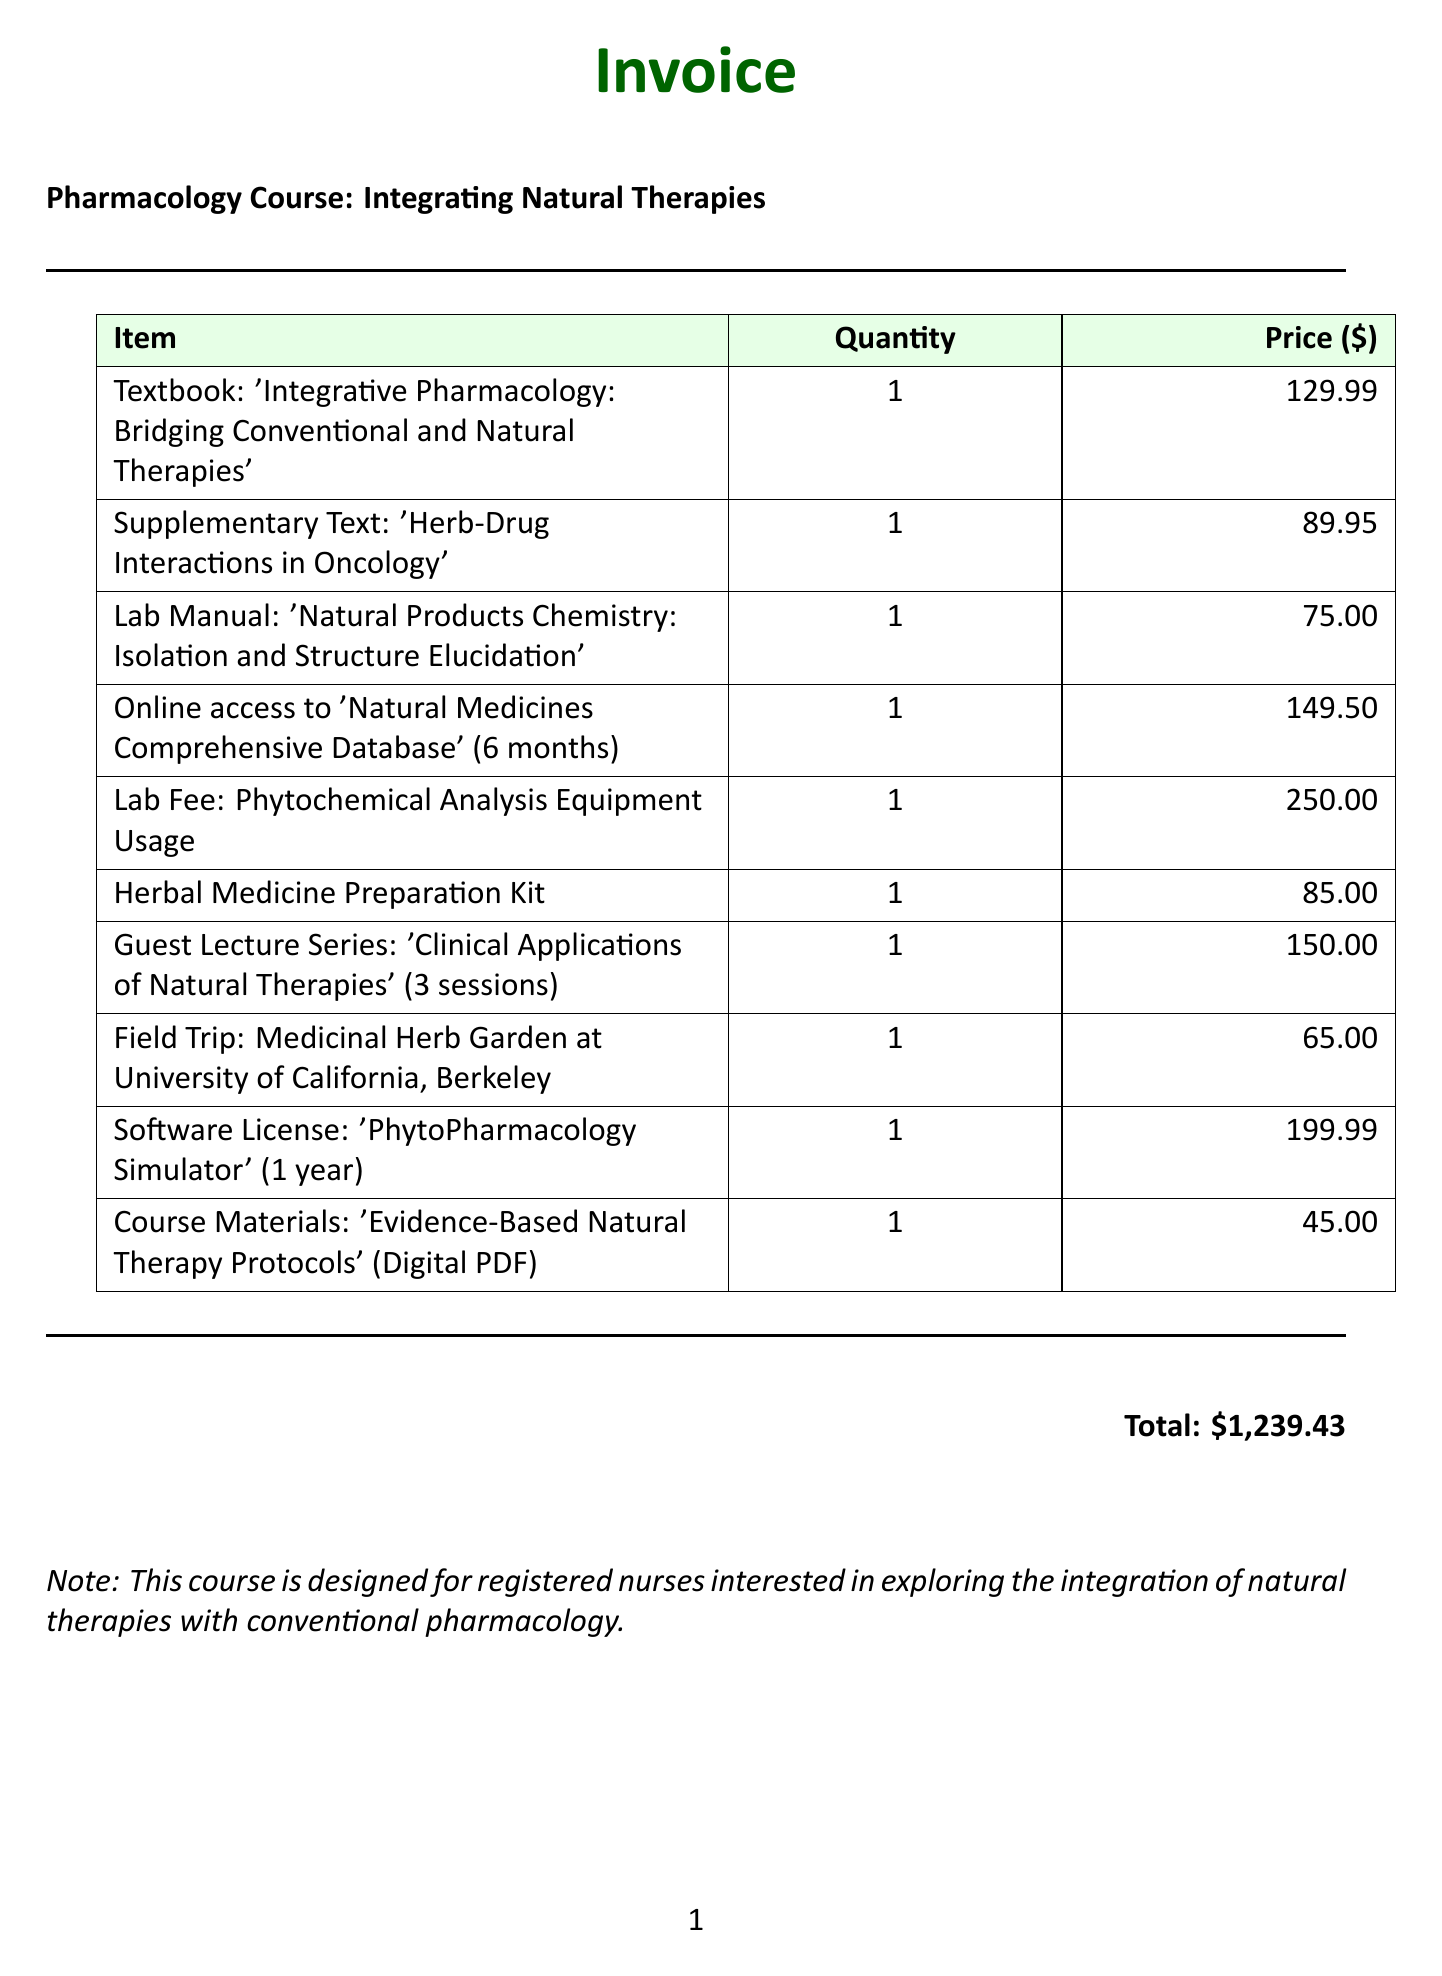What is the title of the main textbook? The title of the main textbook is provided in the list of invoice items.
Answer: 'Integrative Pharmacology: Bridging Conventional and Natural Therapies' Who are the authors of the supplementary text? The authors of the supplementary text are mentioned in the invoice's details.
Answer: Dr. Barrie R. Cassileth What is the total amount of the invoice? The total amount is presented at the bottom of the document, summarizing all charges.
Answer: $1,239.43 How many sessions are included in the Guest Lecture Series? The number of sessions is stated in the description of the Guest Lecture Series.
Answer: 3 What equipment is included in the lab fee? The description of the lab fee specifies the included equipment for analysis.
Answer: HPLC, GC-MS, and NMR spectroscopy What is the price of the Herbal Medicine Preparation Kit? The price is listed next to the item in the invoice.
Answer: 85.00 What is the duration of the online access to the Natural Medicines Comprehensive Database? The duration is indicated for the online access item in the billing statement.
Answer: 6 months Who are the speakers in the Guest Lecture Series? The speakers are listed in the description of the lecture series.
Answer: Dr. Tieraona Low Dog, Dr. Aviva Romm, Dr. David Winston What type of document is this? The content and structure indicate the type of document being an invoice for a course.
Answer: Invoice 